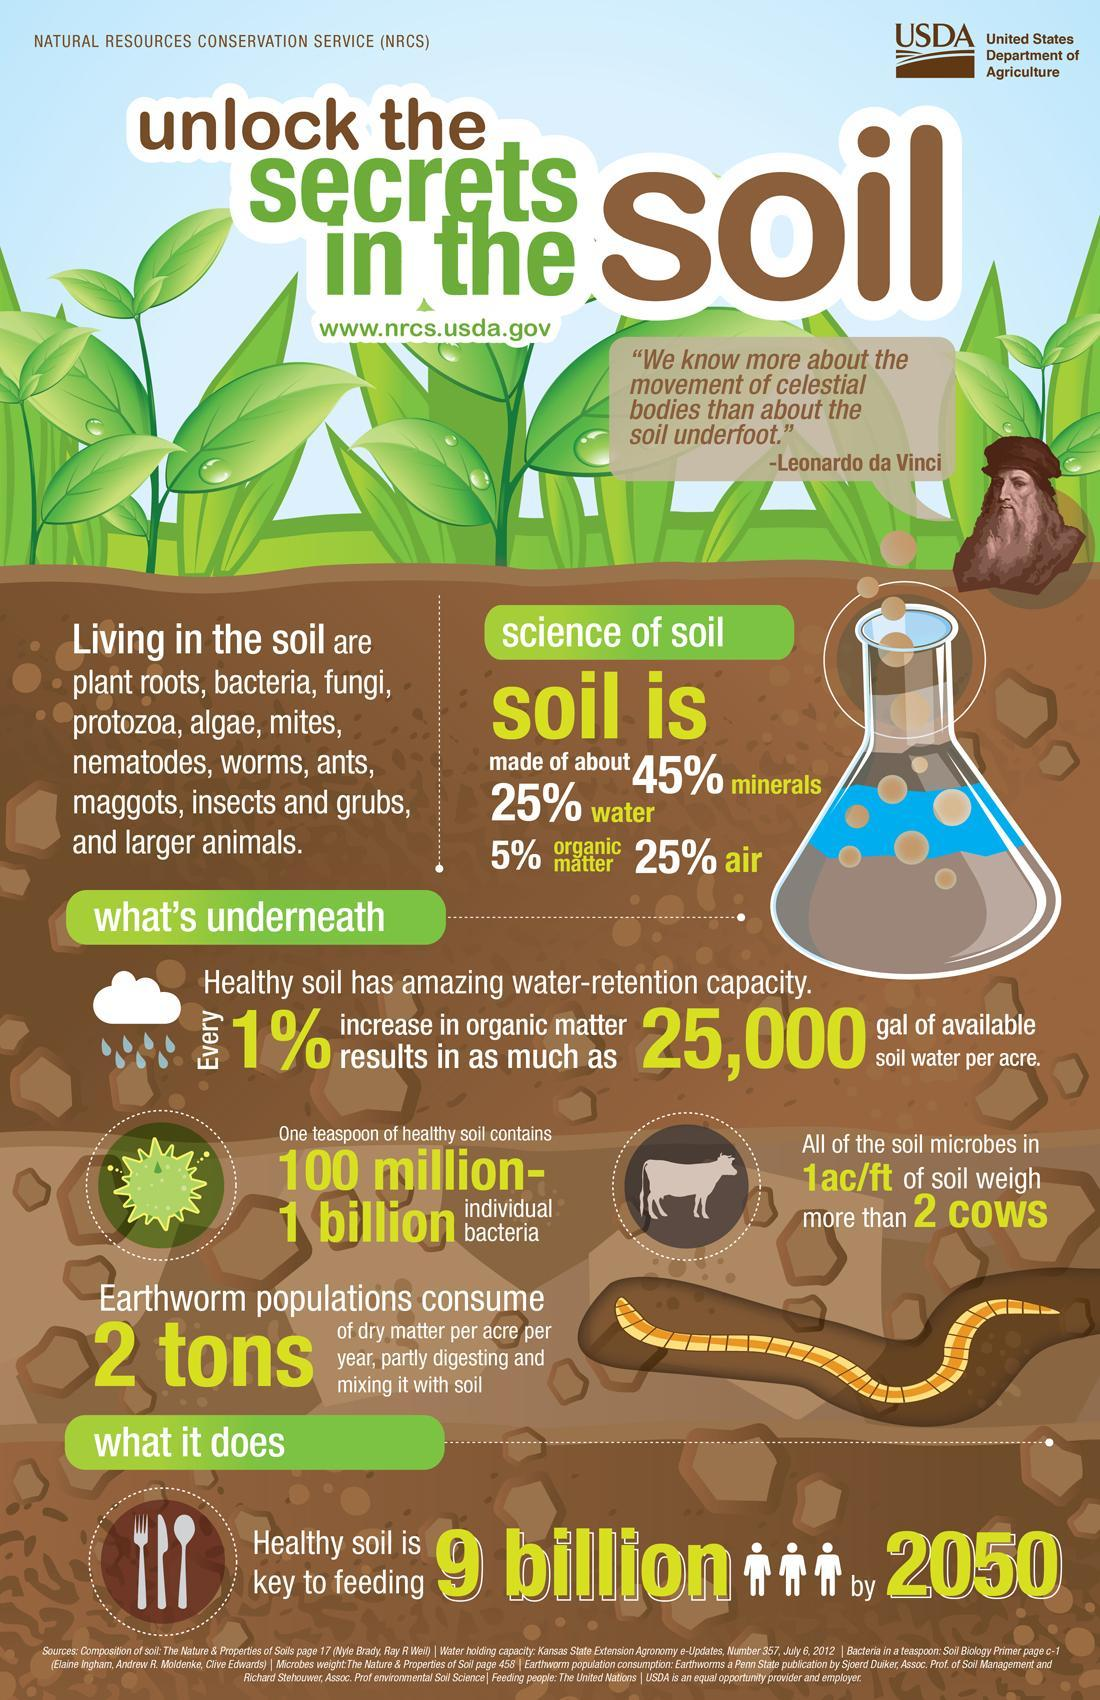What percentage of soil is not air?
Answer the question with a short phrase. 75% What percentage of soil is not water? 75% What percentage of soil is not minerals? 55% What percentage of soil is not organic matter? 95% 